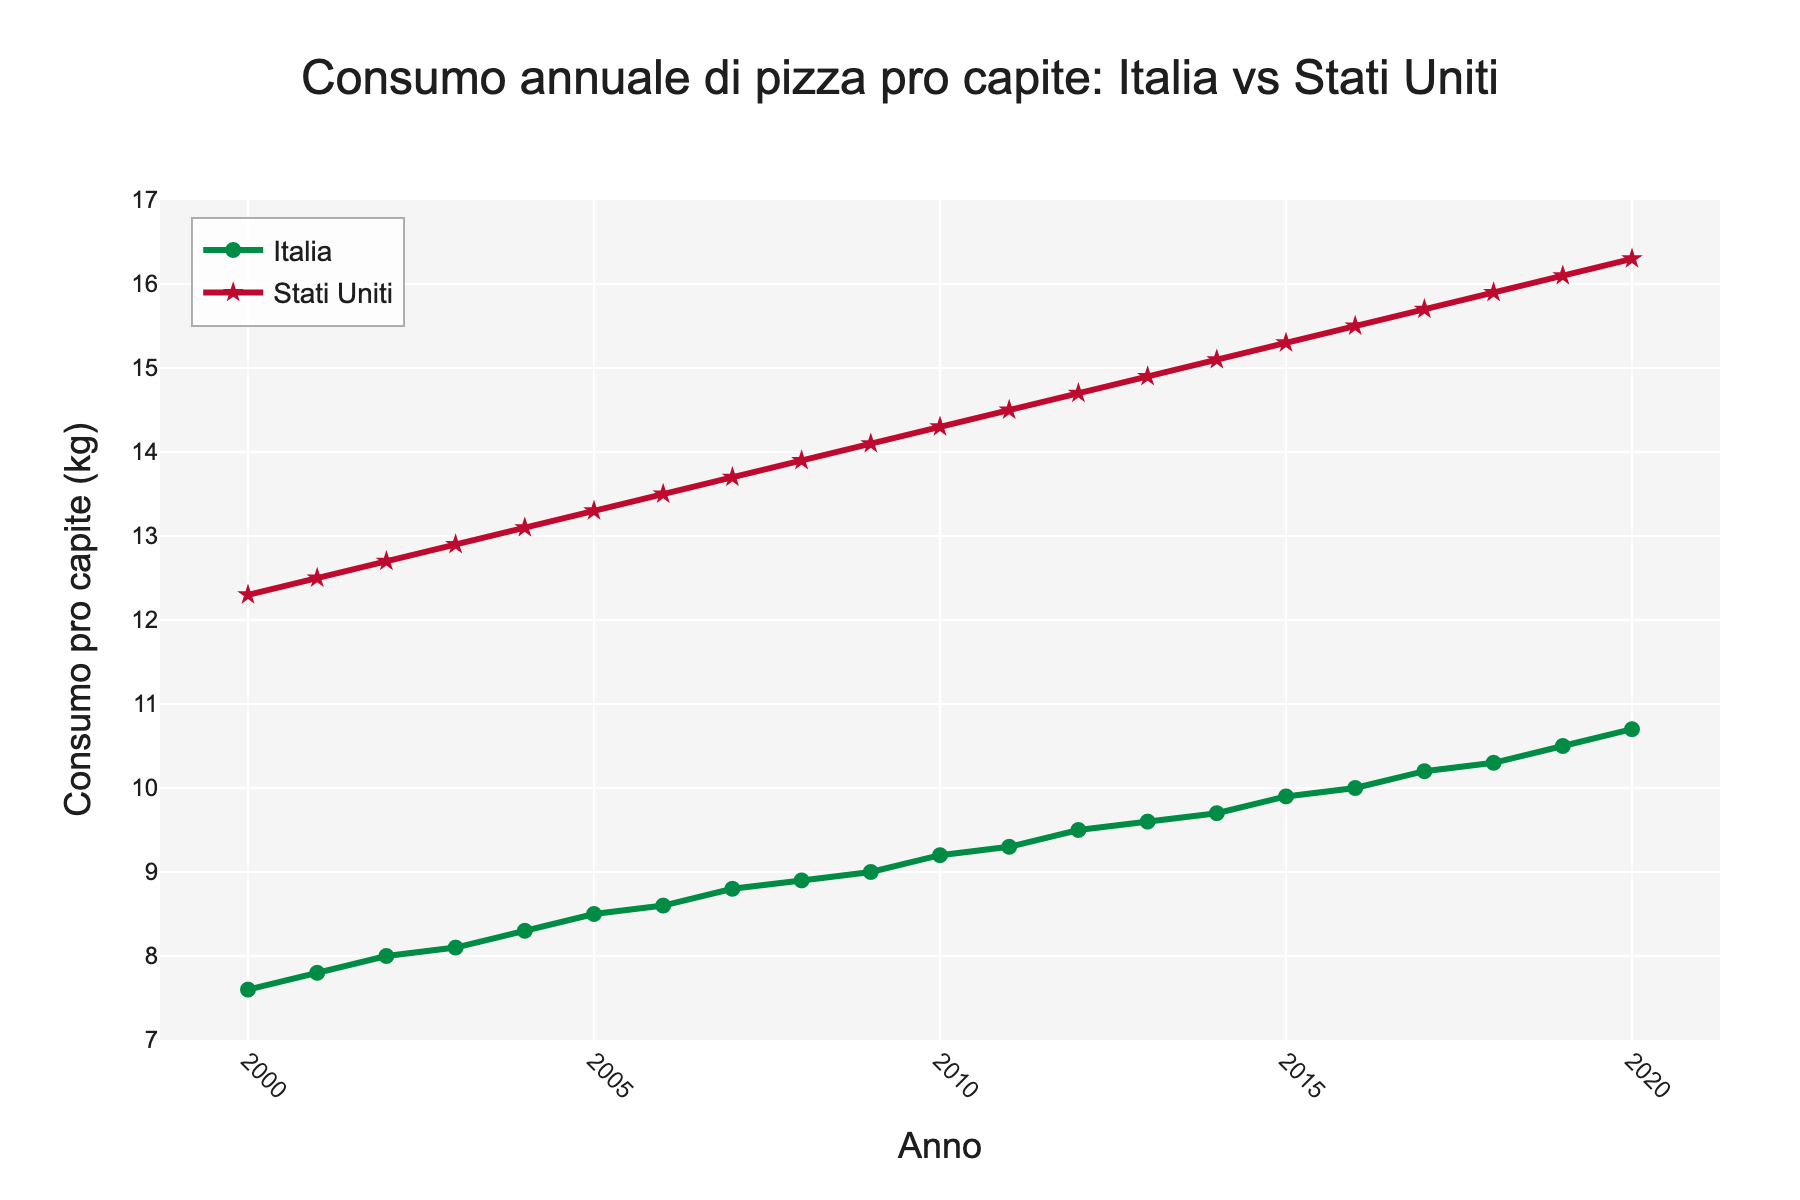What is the per capita pizza consumption in Italy in 2005? To find the per capita pizza consumption in Italy in 2005, locate the year 2005 on the x-axis and then follow the corresponding point on the line for Italy to the y-axis.
Answer: 8.5 kg Which year had the highest per capita pizza consumption in the USA? To find the year with the highest per capita pizza consumption in the USA, locate the peak point of the USA line. Then, trace this point down to the x-axis to find the corresponding year.
Answer: 2020 By how much did the pizza consumption in Italy increase from 2000 to 2020? Locate the values for Italy's pizza consumption in 2000 and 2020 on the y-axis. Subtract the 2000 value from the 2020 value to find the increase. 10.7 kg - 7.6 kg = 3.1 kg
Answer: 3.1 kg What is the average per capita pizza consumption in the USA over the two decades? First, sum the values of pizza consumption in the USA from 2000 to 2020. Then, divide by the number of years (21). Average = (12.3 + 12.5 + ... + 16.3) / 21
Answer: 14.3 kg In which years did Italy's pizza consumption surpass 9 kg per capita? Identify the data points on Italy's line that are above 9 kg on the y-axis. Look at the corresponding years from the x-axis.
Answer: 2009-2020 Did the gap between Italy and USA's pizza consumption increase or decrease from 2000 to 2020? Calculate the difference in per capita consumption between Italy and the USA for 2000 and 2020. Compare the two differences: 2000 (12.3 kg - 7.6 kg = 4.7 kg) and 2020 (16.3 kg - 10.7 kg = 5.6 kg).
Answer: Increase Which country shows a steeper increase in per capita pizza consumption from 2000 to 2020? Compare the slopes of the lines for Italy and the USA. The steeper line indicates a greater rate of increase. The USA increased from 12.3 kg to 16.3 kg (+4), while Italy increased from 7.6 kg to 10.7 kg (+3.1).
Answer: USA What is the visual difference between the markers used for Italy and USA on the plot? Identify the shape and size of the markers for each country. Italy's markers are circular while the USA's markers are star-shaped. Both are of similar size but different symbols.
Answer: Italy: circles, USA: stars 